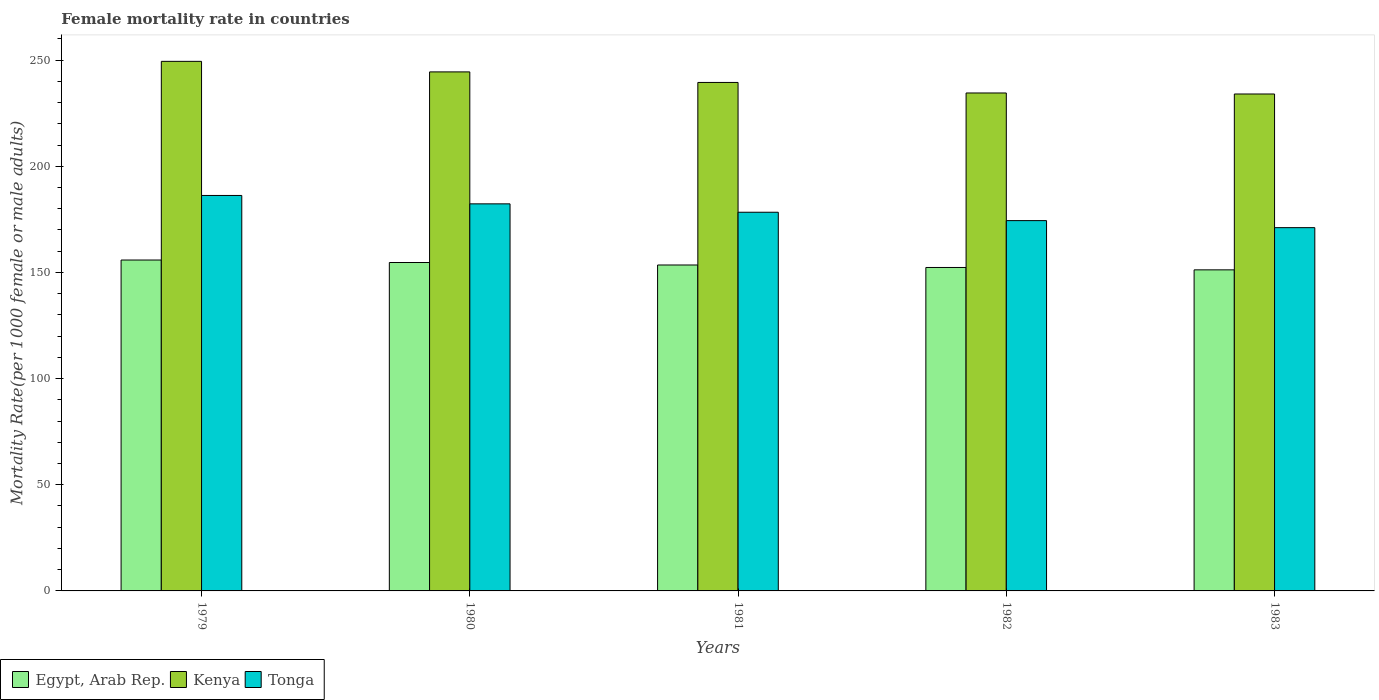How many groups of bars are there?
Provide a succinct answer. 5. Are the number of bars per tick equal to the number of legend labels?
Keep it short and to the point. Yes. How many bars are there on the 5th tick from the left?
Your answer should be compact. 3. How many bars are there on the 2nd tick from the right?
Offer a very short reply. 3. What is the label of the 4th group of bars from the left?
Your response must be concise. 1982. In how many cases, is the number of bars for a given year not equal to the number of legend labels?
Make the answer very short. 0. What is the female mortality rate in Kenya in 1983?
Give a very brief answer. 234.05. Across all years, what is the maximum female mortality rate in Egypt, Arab Rep.?
Offer a very short reply. 155.85. Across all years, what is the minimum female mortality rate in Kenya?
Provide a succinct answer. 234.05. In which year was the female mortality rate in Egypt, Arab Rep. maximum?
Ensure brevity in your answer.  1979. In which year was the female mortality rate in Kenya minimum?
Give a very brief answer. 1983. What is the total female mortality rate in Egypt, Arab Rep. in the graph?
Ensure brevity in your answer.  767.61. What is the difference between the female mortality rate in Tonga in 1980 and that in 1982?
Your response must be concise. 7.9. What is the difference between the female mortality rate in Egypt, Arab Rep. in 1982 and the female mortality rate in Kenya in 1980?
Make the answer very short. -92.12. What is the average female mortality rate in Tonga per year?
Keep it short and to the point. 178.49. In the year 1980, what is the difference between the female mortality rate in Egypt, Arab Rep. and female mortality rate in Tonga?
Your answer should be compact. -27.63. What is the ratio of the female mortality rate in Egypt, Arab Rep. in 1980 to that in 1982?
Offer a very short reply. 1.02. Is the female mortality rate in Egypt, Arab Rep. in 1979 less than that in 1981?
Make the answer very short. No. What is the difference between the highest and the second highest female mortality rate in Egypt, Arab Rep.?
Your answer should be compact. 1.17. What is the difference between the highest and the lowest female mortality rate in Kenya?
Your response must be concise. 15.38. What does the 3rd bar from the left in 1980 represents?
Offer a terse response. Tonga. What does the 3rd bar from the right in 1980 represents?
Provide a short and direct response. Egypt, Arab Rep. How many bars are there?
Give a very brief answer. 15. What is the difference between two consecutive major ticks on the Y-axis?
Provide a short and direct response. 50. Does the graph contain grids?
Give a very brief answer. No. How many legend labels are there?
Provide a succinct answer. 3. How are the legend labels stacked?
Give a very brief answer. Horizontal. What is the title of the graph?
Your answer should be very brief. Female mortality rate in countries. What is the label or title of the Y-axis?
Ensure brevity in your answer.  Mortality Rate(per 1000 female or male adults). What is the Mortality Rate(per 1000 female or male adults) in Egypt, Arab Rep. in 1979?
Your response must be concise. 155.85. What is the Mortality Rate(per 1000 female or male adults) in Kenya in 1979?
Provide a short and direct response. 249.43. What is the Mortality Rate(per 1000 female or male adults) of Tonga in 1979?
Offer a terse response. 186.26. What is the Mortality Rate(per 1000 female or male adults) of Egypt, Arab Rep. in 1980?
Your answer should be compact. 154.68. What is the Mortality Rate(per 1000 female or male adults) in Kenya in 1980?
Keep it short and to the point. 244.46. What is the Mortality Rate(per 1000 female or male adults) in Tonga in 1980?
Your answer should be compact. 182.31. What is the Mortality Rate(per 1000 female or male adults) of Egypt, Arab Rep. in 1981?
Give a very brief answer. 153.51. What is the Mortality Rate(per 1000 female or male adults) of Kenya in 1981?
Ensure brevity in your answer.  239.5. What is the Mortality Rate(per 1000 female or male adults) in Tonga in 1981?
Your answer should be very brief. 178.36. What is the Mortality Rate(per 1000 female or male adults) of Egypt, Arab Rep. in 1982?
Offer a very short reply. 152.34. What is the Mortality Rate(per 1000 female or male adults) of Kenya in 1982?
Make the answer very short. 234.53. What is the Mortality Rate(per 1000 female or male adults) in Tonga in 1982?
Make the answer very short. 174.41. What is the Mortality Rate(per 1000 female or male adults) in Egypt, Arab Rep. in 1983?
Keep it short and to the point. 151.22. What is the Mortality Rate(per 1000 female or male adults) of Kenya in 1983?
Provide a succinct answer. 234.05. What is the Mortality Rate(per 1000 female or male adults) of Tonga in 1983?
Offer a very short reply. 171.1. Across all years, what is the maximum Mortality Rate(per 1000 female or male adults) of Egypt, Arab Rep.?
Provide a short and direct response. 155.85. Across all years, what is the maximum Mortality Rate(per 1000 female or male adults) in Kenya?
Provide a short and direct response. 249.43. Across all years, what is the maximum Mortality Rate(per 1000 female or male adults) of Tonga?
Provide a short and direct response. 186.26. Across all years, what is the minimum Mortality Rate(per 1000 female or male adults) in Egypt, Arab Rep.?
Ensure brevity in your answer.  151.22. Across all years, what is the minimum Mortality Rate(per 1000 female or male adults) of Kenya?
Your answer should be compact. 234.05. Across all years, what is the minimum Mortality Rate(per 1000 female or male adults) in Tonga?
Keep it short and to the point. 171.1. What is the total Mortality Rate(per 1000 female or male adults) in Egypt, Arab Rep. in the graph?
Your response must be concise. 767.61. What is the total Mortality Rate(per 1000 female or male adults) in Kenya in the graph?
Give a very brief answer. 1201.97. What is the total Mortality Rate(per 1000 female or male adults) of Tonga in the graph?
Ensure brevity in your answer.  892.45. What is the difference between the Mortality Rate(per 1000 female or male adults) in Egypt, Arab Rep. in 1979 and that in 1980?
Offer a terse response. 1.17. What is the difference between the Mortality Rate(per 1000 female or male adults) of Kenya in 1979 and that in 1980?
Your answer should be very brief. 4.97. What is the difference between the Mortality Rate(per 1000 female or male adults) in Tonga in 1979 and that in 1980?
Provide a succinct answer. 3.95. What is the difference between the Mortality Rate(per 1000 female or male adults) in Egypt, Arab Rep. in 1979 and that in 1981?
Make the answer very short. 2.34. What is the difference between the Mortality Rate(per 1000 female or male adults) in Kenya in 1979 and that in 1981?
Ensure brevity in your answer.  9.93. What is the difference between the Mortality Rate(per 1000 female or male adults) of Tonga in 1979 and that in 1981?
Make the answer very short. 7.9. What is the difference between the Mortality Rate(per 1000 female or male adults) in Egypt, Arab Rep. in 1979 and that in 1982?
Ensure brevity in your answer.  3.51. What is the difference between the Mortality Rate(per 1000 female or male adults) of Kenya in 1979 and that in 1982?
Ensure brevity in your answer.  14.9. What is the difference between the Mortality Rate(per 1000 female or male adults) in Tonga in 1979 and that in 1982?
Your answer should be compact. 11.85. What is the difference between the Mortality Rate(per 1000 female or male adults) in Egypt, Arab Rep. in 1979 and that in 1983?
Make the answer very short. 4.63. What is the difference between the Mortality Rate(per 1000 female or male adults) of Kenya in 1979 and that in 1983?
Your answer should be compact. 15.38. What is the difference between the Mortality Rate(per 1000 female or male adults) of Tonga in 1979 and that in 1983?
Make the answer very short. 15.16. What is the difference between the Mortality Rate(per 1000 female or male adults) of Egypt, Arab Rep. in 1980 and that in 1981?
Offer a terse response. 1.17. What is the difference between the Mortality Rate(per 1000 female or male adults) in Kenya in 1980 and that in 1981?
Keep it short and to the point. 4.96. What is the difference between the Mortality Rate(per 1000 female or male adults) in Tonga in 1980 and that in 1981?
Your answer should be very brief. 3.95. What is the difference between the Mortality Rate(per 1000 female or male adults) of Egypt, Arab Rep. in 1980 and that in 1982?
Give a very brief answer. 2.34. What is the difference between the Mortality Rate(per 1000 female or male adults) in Kenya in 1980 and that in 1982?
Provide a succinct answer. 9.93. What is the difference between the Mortality Rate(per 1000 female or male adults) in Tonga in 1980 and that in 1982?
Your answer should be compact. 7.9. What is the difference between the Mortality Rate(per 1000 female or male adults) of Egypt, Arab Rep. in 1980 and that in 1983?
Make the answer very short. 3.46. What is the difference between the Mortality Rate(per 1000 female or male adults) of Kenya in 1980 and that in 1983?
Offer a very short reply. 10.41. What is the difference between the Mortality Rate(per 1000 female or male adults) in Tonga in 1980 and that in 1983?
Make the answer very short. 11.21. What is the difference between the Mortality Rate(per 1000 female or male adults) in Egypt, Arab Rep. in 1981 and that in 1982?
Ensure brevity in your answer.  1.17. What is the difference between the Mortality Rate(per 1000 female or male adults) of Kenya in 1981 and that in 1982?
Your answer should be very brief. 4.97. What is the difference between the Mortality Rate(per 1000 female or male adults) in Tonga in 1981 and that in 1982?
Offer a very short reply. 3.95. What is the difference between the Mortality Rate(per 1000 female or male adults) of Egypt, Arab Rep. in 1981 and that in 1983?
Keep it short and to the point. 2.29. What is the difference between the Mortality Rate(per 1000 female or male adults) in Kenya in 1981 and that in 1983?
Your answer should be very brief. 5.45. What is the difference between the Mortality Rate(per 1000 female or male adults) in Tonga in 1981 and that in 1983?
Offer a very short reply. 7.26. What is the difference between the Mortality Rate(per 1000 female or male adults) in Egypt, Arab Rep. in 1982 and that in 1983?
Provide a short and direct response. 1.12. What is the difference between the Mortality Rate(per 1000 female or male adults) in Kenya in 1982 and that in 1983?
Your answer should be compact. 0.48. What is the difference between the Mortality Rate(per 1000 female or male adults) of Tonga in 1982 and that in 1983?
Your response must be concise. 3.31. What is the difference between the Mortality Rate(per 1000 female or male adults) in Egypt, Arab Rep. in 1979 and the Mortality Rate(per 1000 female or male adults) in Kenya in 1980?
Make the answer very short. -88.61. What is the difference between the Mortality Rate(per 1000 female or male adults) in Egypt, Arab Rep. in 1979 and the Mortality Rate(per 1000 female or male adults) in Tonga in 1980?
Make the answer very short. -26.46. What is the difference between the Mortality Rate(per 1000 female or male adults) of Kenya in 1979 and the Mortality Rate(per 1000 female or male adults) of Tonga in 1980?
Offer a terse response. 67.12. What is the difference between the Mortality Rate(per 1000 female or male adults) of Egypt, Arab Rep. in 1979 and the Mortality Rate(per 1000 female or male adults) of Kenya in 1981?
Offer a very short reply. -83.65. What is the difference between the Mortality Rate(per 1000 female or male adults) of Egypt, Arab Rep. in 1979 and the Mortality Rate(per 1000 female or male adults) of Tonga in 1981?
Your answer should be very brief. -22.51. What is the difference between the Mortality Rate(per 1000 female or male adults) in Kenya in 1979 and the Mortality Rate(per 1000 female or male adults) in Tonga in 1981?
Keep it short and to the point. 71.07. What is the difference between the Mortality Rate(per 1000 female or male adults) in Egypt, Arab Rep. in 1979 and the Mortality Rate(per 1000 female or male adults) in Kenya in 1982?
Provide a succinct answer. -78.68. What is the difference between the Mortality Rate(per 1000 female or male adults) of Egypt, Arab Rep. in 1979 and the Mortality Rate(per 1000 female or male adults) of Tonga in 1982?
Your response must be concise. -18.56. What is the difference between the Mortality Rate(per 1000 female or male adults) in Kenya in 1979 and the Mortality Rate(per 1000 female or male adults) in Tonga in 1982?
Your answer should be compact. 75.02. What is the difference between the Mortality Rate(per 1000 female or male adults) in Egypt, Arab Rep. in 1979 and the Mortality Rate(per 1000 female or male adults) in Kenya in 1983?
Your response must be concise. -78.2. What is the difference between the Mortality Rate(per 1000 female or male adults) in Egypt, Arab Rep. in 1979 and the Mortality Rate(per 1000 female or male adults) in Tonga in 1983?
Your answer should be compact. -15.25. What is the difference between the Mortality Rate(per 1000 female or male adults) of Kenya in 1979 and the Mortality Rate(per 1000 female or male adults) of Tonga in 1983?
Provide a succinct answer. 78.32. What is the difference between the Mortality Rate(per 1000 female or male adults) of Egypt, Arab Rep. in 1980 and the Mortality Rate(per 1000 female or male adults) of Kenya in 1981?
Provide a succinct answer. -84.82. What is the difference between the Mortality Rate(per 1000 female or male adults) in Egypt, Arab Rep. in 1980 and the Mortality Rate(per 1000 female or male adults) in Tonga in 1981?
Make the answer very short. -23.68. What is the difference between the Mortality Rate(per 1000 female or male adults) in Kenya in 1980 and the Mortality Rate(per 1000 female or male adults) in Tonga in 1981?
Offer a very short reply. 66.1. What is the difference between the Mortality Rate(per 1000 female or male adults) of Egypt, Arab Rep. in 1980 and the Mortality Rate(per 1000 female or male adults) of Kenya in 1982?
Your answer should be very brief. -79.85. What is the difference between the Mortality Rate(per 1000 female or male adults) in Egypt, Arab Rep. in 1980 and the Mortality Rate(per 1000 female or male adults) in Tonga in 1982?
Make the answer very short. -19.73. What is the difference between the Mortality Rate(per 1000 female or male adults) of Kenya in 1980 and the Mortality Rate(per 1000 female or male adults) of Tonga in 1982?
Ensure brevity in your answer.  70.05. What is the difference between the Mortality Rate(per 1000 female or male adults) of Egypt, Arab Rep. in 1980 and the Mortality Rate(per 1000 female or male adults) of Kenya in 1983?
Provide a short and direct response. -79.37. What is the difference between the Mortality Rate(per 1000 female or male adults) in Egypt, Arab Rep. in 1980 and the Mortality Rate(per 1000 female or male adults) in Tonga in 1983?
Provide a succinct answer. -16.42. What is the difference between the Mortality Rate(per 1000 female or male adults) of Kenya in 1980 and the Mortality Rate(per 1000 female or male adults) of Tonga in 1983?
Your answer should be compact. 73.36. What is the difference between the Mortality Rate(per 1000 female or male adults) of Egypt, Arab Rep. in 1981 and the Mortality Rate(per 1000 female or male adults) of Kenya in 1982?
Ensure brevity in your answer.  -81.02. What is the difference between the Mortality Rate(per 1000 female or male adults) in Egypt, Arab Rep. in 1981 and the Mortality Rate(per 1000 female or male adults) in Tonga in 1982?
Give a very brief answer. -20.9. What is the difference between the Mortality Rate(per 1000 female or male adults) in Kenya in 1981 and the Mortality Rate(per 1000 female or male adults) in Tonga in 1982?
Provide a succinct answer. 65.08. What is the difference between the Mortality Rate(per 1000 female or male adults) of Egypt, Arab Rep. in 1981 and the Mortality Rate(per 1000 female or male adults) of Kenya in 1983?
Your answer should be compact. -80.54. What is the difference between the Mortality Rate(per 1000 female or male adults) in Egypt, Arab Rep. in 1981 and the Mortality Rate(per 1000 female or male adults) in Tonga in 1983?
Ensure brevity in your answer.  -17.59. What is the difference between the Mortality Rate(per 1000 female or male adults) of Kenya in 1981 and the Mortality Rate(per 1000 female or male adults) of Tonga in 1983?
Give a very brief answer. 68.39. What is the difference between the Mortality Rate(per 1000 female or male adults) of Egypt, Arab Rep. in 1982 and the Mortality Rate(per 1000 female or male adults) of Kenya in 1983?
Offer a very short reply. -81.71. What is the difference between the Mortality Rate(per 1000 female or male adults) in Egypt, Arab Rep. in 1982 and the Mortality Rate(per 1000 female or male adults) in Tonga in 1983?
Give a very brief answer. -18.76. What is the difference between the Mortality Rate(per 1000 female or male adults) in Kenya in 1982 and the Mortality Rate(per 1000 female or male adults) in Tonga in 1983?
Your response must be concise. 63.43. What is the average Mortality Rate(per 1000 female or male adults) of Egypt, Arab Rep. per year?
Provide a succinct answer. 153.52. What is the average Mortality Rate(per 1000 female or male adults) of Kenya per year?
Your answer should be very brief. 240.39. What is the average Mortality Rate(per 1000 female or male adults) of Tonga per year?
Keep it short and to the point. 178.49. In the year 1979, what is the difference between the Mortality Rate(per 1000 female or male adults) in Egypt, Arab Rep. and Mortality Rate(per 1000 female or male adults) in Kenya?
Offer a very short reply. -93.58. In the year 1979, what is the difference between the Mortality Rate(per 1000 female or male adults) in Egypt, Arab Rep. and Mortality Rate(per 1000 female or male adults) in Tonga?
Your answer should be compact. -30.41. In the year 1979, what is the difference between the Mortality Rate(per 1000 female or male adults) of Kenya and Mortality Rate(per 1000 female or male adults) of Tonga?
Your response must be concise. 63.17. In the year 1980, what is the difference between the Mortality Rate(per 1000 female or male adults) of Egypt, Arab Rep. and Mortality Rate(per 1000 female or male adults) of Kenya?
Provide a succinct answer. -89.78. In the year 1980, what is the difference between the Mortality Rate(per 1000 female or male adults) in Egypt, Arab Rep. and Mortality Rate(per 1000 female or male adults) in Tonga?
Ensure brevity in your answer.  -27.63. In the year 1980, what is the difference between the Mortality Rate(per 1000 female or male adults) in Kenya and Mortality Rate(per 1000 female or male adults) in Tonga?
Your answer should be compact. 62.15. In the year 1981, what is the difference between the Mortality Rate(per 1000 female or male adults) in Egypt, Arab Rep. and Mortality Rate(per 1000 female or male adults) in Kenya?
Make the answer very short. -85.99. In the year 1981, what is the difference between the Mortality Rate(per 1000 female or male adults) of Egypt, Arab Rep. and Mortality Rate(per 1000 female or male adults) of Tonga?
Give a very brief answer. -24.85. In the year 1981, what is the difference between the Mortality Rate(per 1000 female or male adults) of Kenya and Mortality Rate(per 1000 female or male adults) of Tonga?
Ensure brevity in your answer.  61.14. In the year 1982, what is the difference between the Mortality Rate(per 1000 female or male adults) in Egypt, Arab Rep. and Mortality Rate(per 1000 female or male adults) in Kenya?
Give a very brief answer. -82.19. In the year 1982, what is the difference between the Mortality Rate(per 1000 female or male adults) of Egypt, Arab Rep. and Mortality Rate(per 1000 female or male adults) of Tonga?
Offer a terse response. -22.07. In the year 1982, what is the difference between the Mortality Rate(per 1000 female or male adults) of Kenya and Mortality Rate(per 1000 female or male adults) of Tonga?
Provide a succinct answer. 60.12. In the year 1983, what is the difference between the Mortality Rate(per 1000 female or male adults) of Egypt, Arab Rep. and Mortality Rate(per 1000 female or male adults) of Kenya?
Offer a terse response. -82.83. In the year 1983, what is the difference between the Mortality Rate(per 1000 female or male adults) of Egypt, Arab Rep. and Mortality Rate(per 1000 female or male adults) of Tonga?
Keep it short and to the point. -19.88. In the year 1983, what is the difference between the Mortality Rate(per 1000 female or male adults) of Kenya and Mortality Rate(per 1000 female or male adults) of Tonga?
Ensure brevity in your answer.  62.95. What is the ratio of the Mortality Rate(per 1000 female or male adults) of Egypt, Arab Rep. in 1979 to that in 1980?
Ensure brevity in your answer.  1.01. What is the ratio of the Mortality Rate(per 1000 female or male adults) of Kenya in 1979 to that in 1980?
Keep it short and to the point. 1.02. What is the ratio of the Mortality Rate(per 1000 female or male adults) in Tonga in 1979 to that in 1980?
Offer a very short reply. 1.02. What is the ratio of the Mortality Rate(per 1000 female or male adults) of Egypt, Arab Rep. in 1979 to that in 1981?
Make the answer very short. 1.02. What is the ratio of the Mortality Rate(per 1000 female or male adults) in Kenya in 1979 to that in 1981?
Provide a short and direct response. 1.04. What is the ratio of the Mortality Rate(per 1000 female or male adults) in Tonga in 1979 to that in 1981?
Provide a short and direct response. 1.04. What is the ratio of the Mortality Rate(per 1000 female or male adults) in Egypt, Arab Rep. in 1979 to that in 1982?
Give a very brief answer. 1.02. What is the ratio of the Mortality Rate(per 1000 female or male adults) in Kenya in 1979 to that in 1982?
Make the answer very short. 1.06. What is the ratio of the Mortality Rate(per 1000 female or male adults) in Tonga in 1979 to that in 1982?
Offer a terse response. 1.07. What is the ratio of the Mortality Rate(per 1000 female or male adults) of Egypt, Arab Rep. in 1979 to that in 1983?
Keep it short and to the point. 1.03. What is the ratio of the Mortality Rate(per 1000 female or male adults) in Kenya in 1979 to that in 1983?
Provide a succinct answer. 1.07. What is the ratio of the Mortality Rate(per 1000 female or male adults) in Tonga in 1979 to that in 1983?
Keep it short and to the point. 1.09. What is the ratio of the Mortality Rate(per 1000 female or male adults) of Egypt, Arab Rep. in 1980 to that in 1981?
Offer a terse response. 1.01. What is the ratio of the Mortality Rate(per 1000 female or male adults) in Kenya in 1980 to that in 1981?
Your answer should be very brief. 1.02. What is the ratio of the Mortality Rate(per 1000 female or male adults) in Tonga in 1980 to that in 1981?
Offer a very short reply. 1.02. What is the ratio of the Mortality Rate(per 1000 female or male adults) of Egypt, Arab Rep. in 1980 to that in 1982?
Keep it short and to the point. 1.02. What is the ratio of the Mortality Rate(per 1000 female or male adults) in Kenya in 1980 to that in 1982?
Offer a terse response. 1.04. What is the ratio of the Mortality Rate(per 1000 female or male adults) in Tonga in 1980 to that in 1982?
Keep it short and to the point. 1.05. What is the ratio of the Mortality Rate(per 1000 female or male adults) of Egypt, Arab Rep. in 1980 to that in 1983?
Provide a succinct answer. 1.02. What is the ratio of the Mortality Rate(per 1000 female or male adults) in Kenya in 1980 to that in 1983?
Offer a very short reply. 1.04. What is the ratio of the Mortality Rate(per 1000 female or male adults) of Tonga in 1980 to that in 1983?
Your response must be concise. 1.07. What is the ratio of the Mortality Rate(per 1000 female or male adults) in Egypt, Arab Rep. in 1981 to that in 1982?
Your answer should be very brief. 1.01. What is the ratio of the Mortality Rate(per 1000 female or male adults) of Kenya in 1981 to that in 1982?
Offer a very short reply. 1.02. What is the ratio of the Mortality Rate(per 1000 female or male adults) in Tonga in 1981 to that in 1982?
Offer a very short reply. 1.02. What is the ratio of the Mortality Rate(per 1000 female or male adults) of Egypt, Arab Rep. in 1981 to that in 1983?
Your answer should be very brief. 1.02. What is the ratio of the Mortality Rate(per 1000 female or male adults) of Kenya in 1981 to that in 1983?
Provide a succinct answer. 1.02. What is the ratio of the Mortality Rate(per 1000 female or male adults) of Tonga in 1981 to that in 1983?
Give a very brief answer. 1.04. What is the ratio of the Mortality Rate(per 1000 female or male adults) in Egypt, Arab Rep. in 1982 to that in 1983?
Make the answer very short. 1.01. What is the ratio of the Mortality Rate(per 1000 female or male adults) of Kenya in 1982 to that in 1983?
Provide a short and direct response. 1. What is the ratio of the Mortality Rate(per 1000 female or male adults) of Tonga in 1982 to that in 1983?
Your answer should be very brief. 1.02. What is the difference between the highest and the second highest Mortality Rate(per 1000 female or male adults) in Egypt, Arab Rep.?
Your answer should be very brief. 1.17. What is the difference between the highest and the second highest Mortality Rate(per 1000 female or male adults) of Kenya?
Your answer should be very brief. 4.97. What is the difference between the highest and the second highest Mortality Rate(per 1000 female or male adults) of Tonga?
Your response must be concise. 3.95. What is the difference between the highest and the lowest Mortality Rate(per 1000 female or male adults) of Egypt, Arab Rep.?
Keep it short and to the point. 4.63. What is the difference between the highest and the lowest Mortality Rate(per 1000 female or male adults) of Kenya?
Your response must be concise. 15.38. What is the difference between the highest and the lowest Mortality Rate(per 1000 female or male adults) in Tonga?
Your response must be concise. 15.16. 